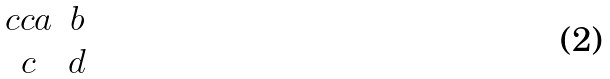Convert formula to latex. <formula><loc_0><loc_0><loc_500><loc_500>\begin{matrix} { c c } a & b \\ c & d \end{matrix}</formula> 